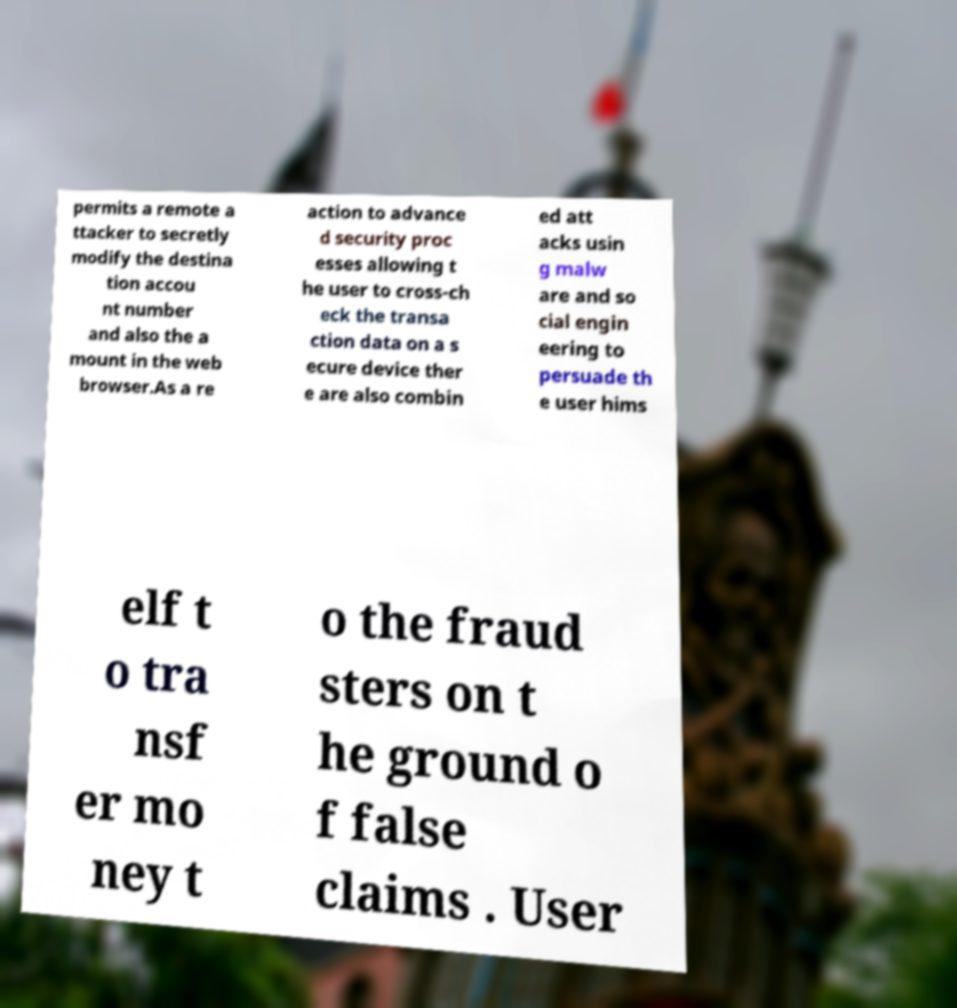Please identify and transcribe the text found in this image. permits a remote a ttacker to secretly modify the destina tion accou nt number and also the a mount in the web browser.As a re action to advance d security proc esses allowing t he user to cross-ch eck the transa ction data on a s ecure device ther e are also combin ed att acks usin g malw are and so cial engin eering to persuade th e user hims elf t o tra nsf er mo ney t o the fraud sters on t he ground o f false claims . User 